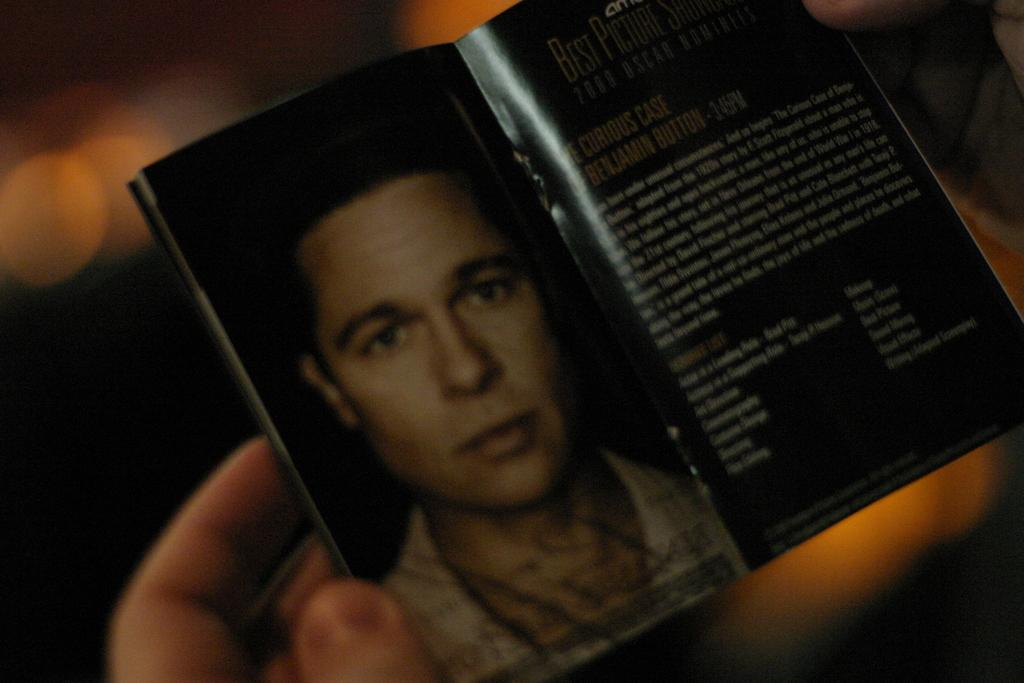What can be seen being held by the person in the image? A person is holding a book in the image. What is depicted in the book? The book contains an image of a person. Is there any text or description in the book? Yes, there is some description in the book. Can you describe the background of the image? The background of the image is blurred. How many squares are visible on the kite in the image? There is no kite present in the image, so it is not possible to determine the number of squares on it. 